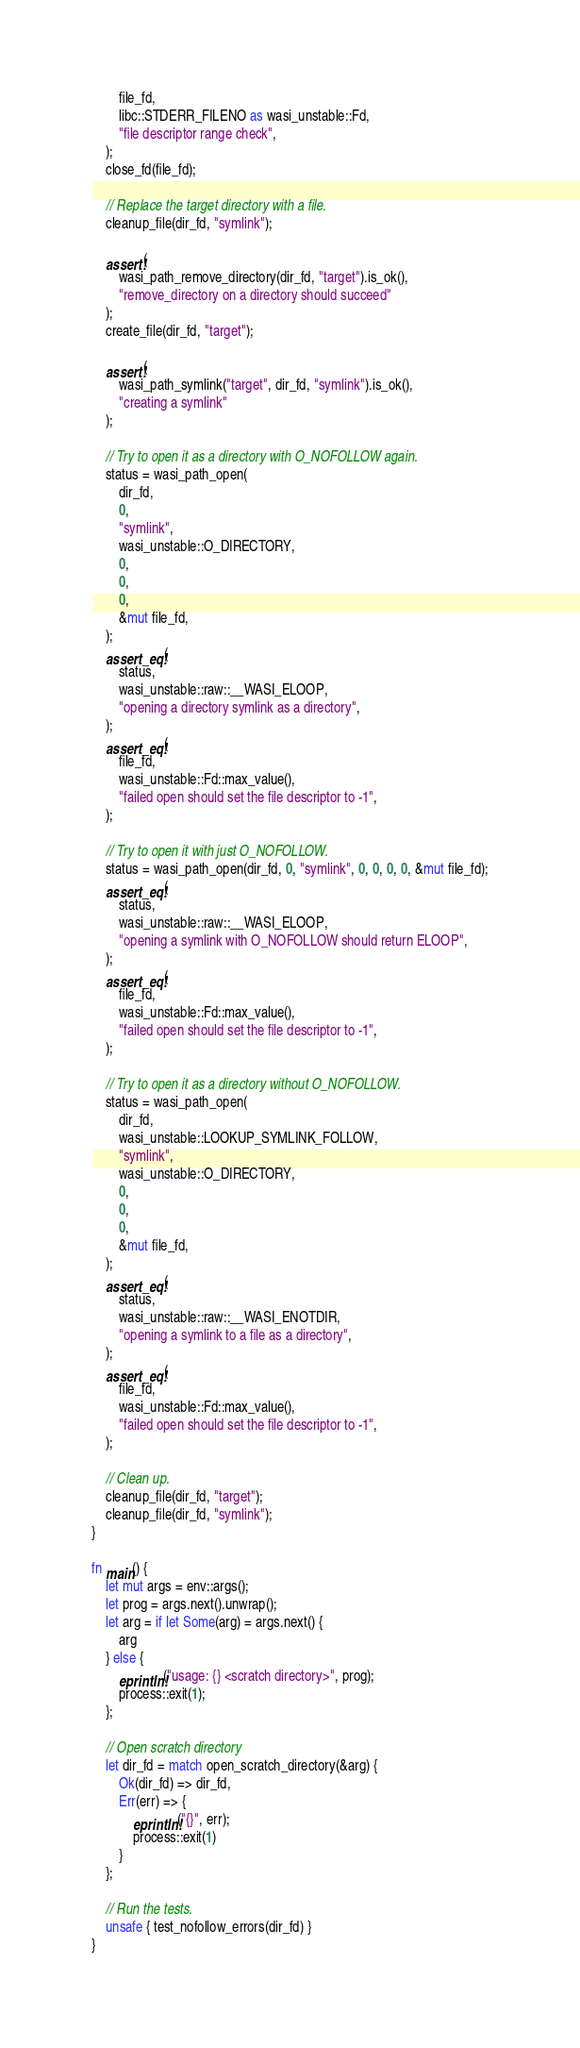<code> <loc_0><loc_0><loc_500><loc_500><_Rust_>        file_fd,
        libc::STDERR_FILENO as wasi_unstable::Fd,
        "file descriptor range check",
    );
    close_fd(file_fd);

    // Replace the target directory with a file.
    cleanup_file(dir_fd, "symlink");

    assert!(
        wasi_path_remove_directory(dir_fd, "target").is_ok(),
        "remove_directory on a directory should succeed"
    );
    create_file(dir_fd, "target");

    assert!(
        wasi_path_symlink("target", dir_fd, "symlink").is_ok(),
        "creating a symlink"
    );

    // Try to open it as a directory with O_NOFOLLOW again.
    status = wasi_path_open(
        dir_fd,
        0,
        "symlink",
        wasi_unstable::O_DIRECTORY,
        0,
        0,
        0,
        &mut file_fd,
    );
    assert_eq!(
        status,
        wasi_unstable::raw::__WASI_ELOOP,
        "opening a directory symlink as a directory",
    );
    assert_eq!(
        file_fd,
        wasi_unstable::Fd::max_value(),
        "failed open should set the file descriptor to -1",
    );

    // Try to open it with just O_NOFOLLOW.
    status = wasi_path_open(dir_fd, 0, "symlink", 0, 0, 0, 0, &mut file_fd);
    assert_eq!(
        status,
        wasi_unstable::raw::__WASI_ELOOP,
        "opening a symlink with O_NOFOLLOW should return ELOOP",
    );
    assert_eq!(
        file_fd,
        wasi_unstable::Fd::max_value(),
        "failed open should set the file descriptor to -1",
    );

    // Try to open it as a directory without O_NOFOLLOW.
    status = wasi_path_open(
        dir_fd,
        wasi_unstable::LOOKUP_SYMLINK_FOLLOW,
        "symlink",
        wasi_unstable::O_DIRECTORY,
        0,
        0,
        0,
        &mut file_fd,
    );
    assert_eq!(
        status,
        wasi_unstable::raw::__WASI_ENOTDIR,
        "opening a symlink to a file as a directory",
    );
    assert_eq!(
        file_fd,
        wasi_unstable::Fd::max_value(),
        "failed open should set the file descriptor to -1",
    );

    // Clean up.
    cleanup_file(dir_fd, "target");
    cleanup_file(dir_fd, "symlink");
}

fn main() {
    let mut args = env::args();
    let prog = args.next().unwrap();
    let arg = if let Some(arg) = args.next() {
        arg
    } else {
        eprintln!("usage: {} <scratch directory>", prog);
        process::exit(1);
    };

    // Open scratch directory
    let dir_fd = match open_scratch_directory(&arg) {
        Ok(dir_fd) => dir_fd,
        Err(err) => {
            eprintln!("{}", err);
            process::exit(1)
        }
    };

    // Run the tests.
    unsafe { test_nofollow_errors(dir_fd) }
}
</code> 